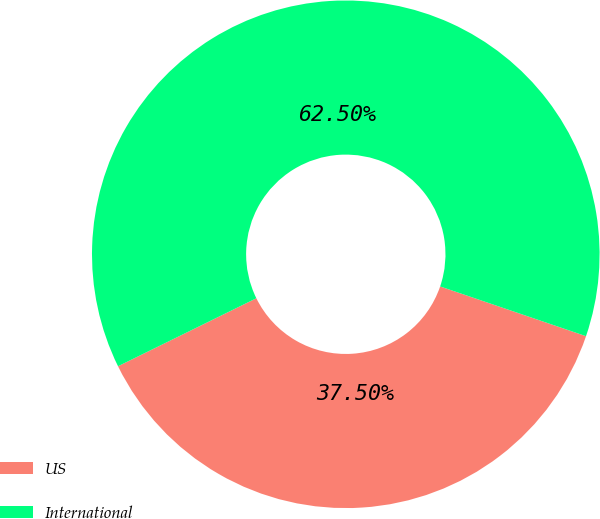Convert chart to OTSL. <chart><loc_0><loc_0><loc_500><loc_500><pie_chart><fcel>US<fcel>International<nl><fcel>37.5%<fcel>62.5%<nl></chart> 